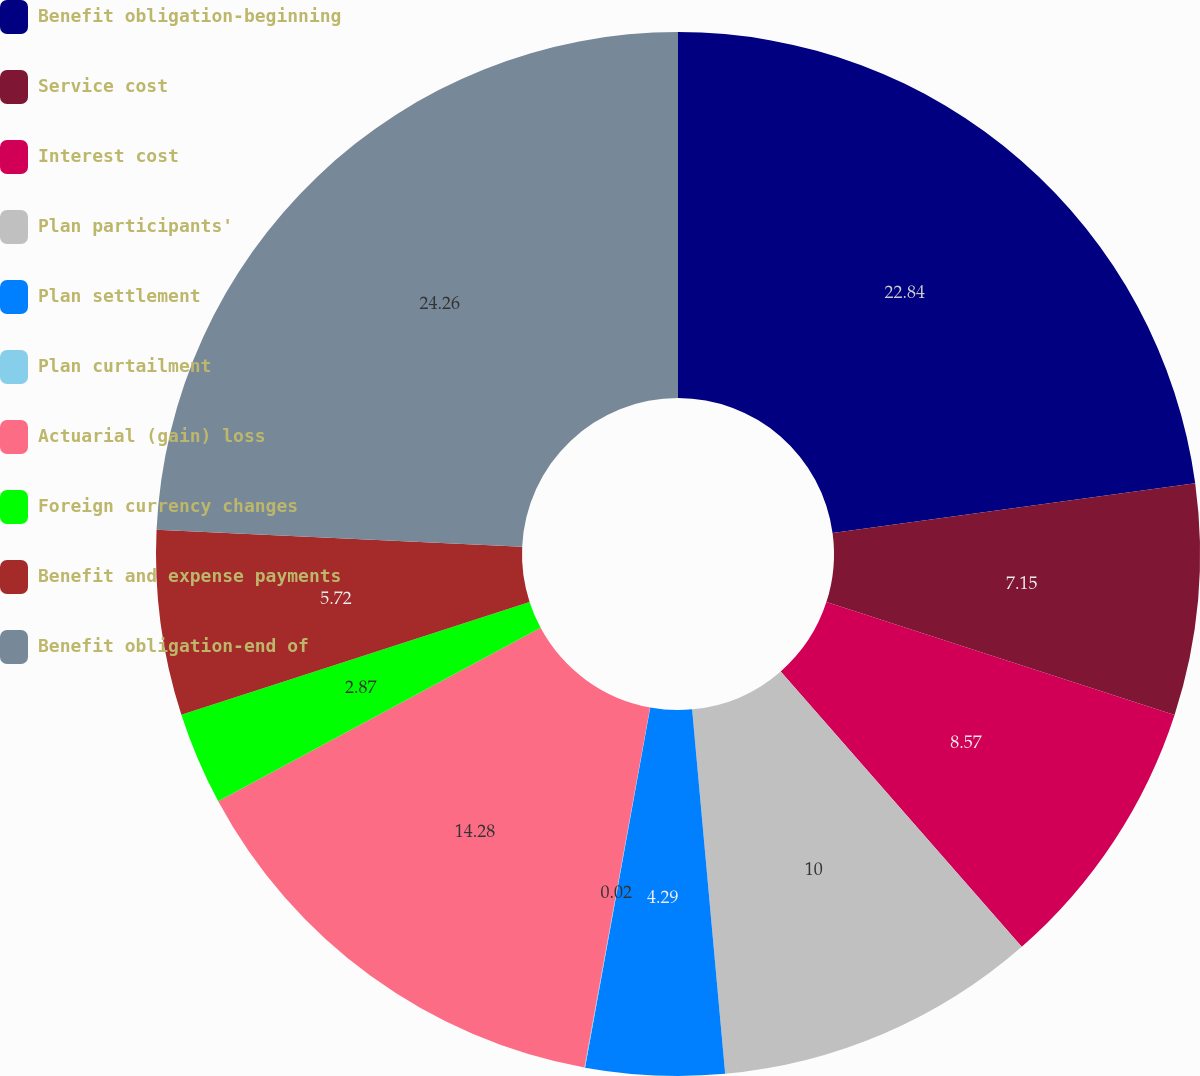<chart> <loc_0><loc_0><loc_500><loc_500><pie_chart><fcel>Benefit obligation-beginning<fcel>Service cost<fcel>Interest cost<fcel>Plan participants'<fcel>Plan settlement<fcel>Plan curtailment<fcel>Actuarial (gain) loss<fcel>Foreign currency changes<fcel>Benefit and expense payments<fcel>Benefit obligation-end of<nl><fcel>22.84%<fcel>7.15%<fcel>8.57%<fcel>10.0%<fcel>4.29%<fcel>0.02%<fcel>14.28%<fcel>2.87%<fcel>5.72%<fcel>24.26%<nl></chart> 